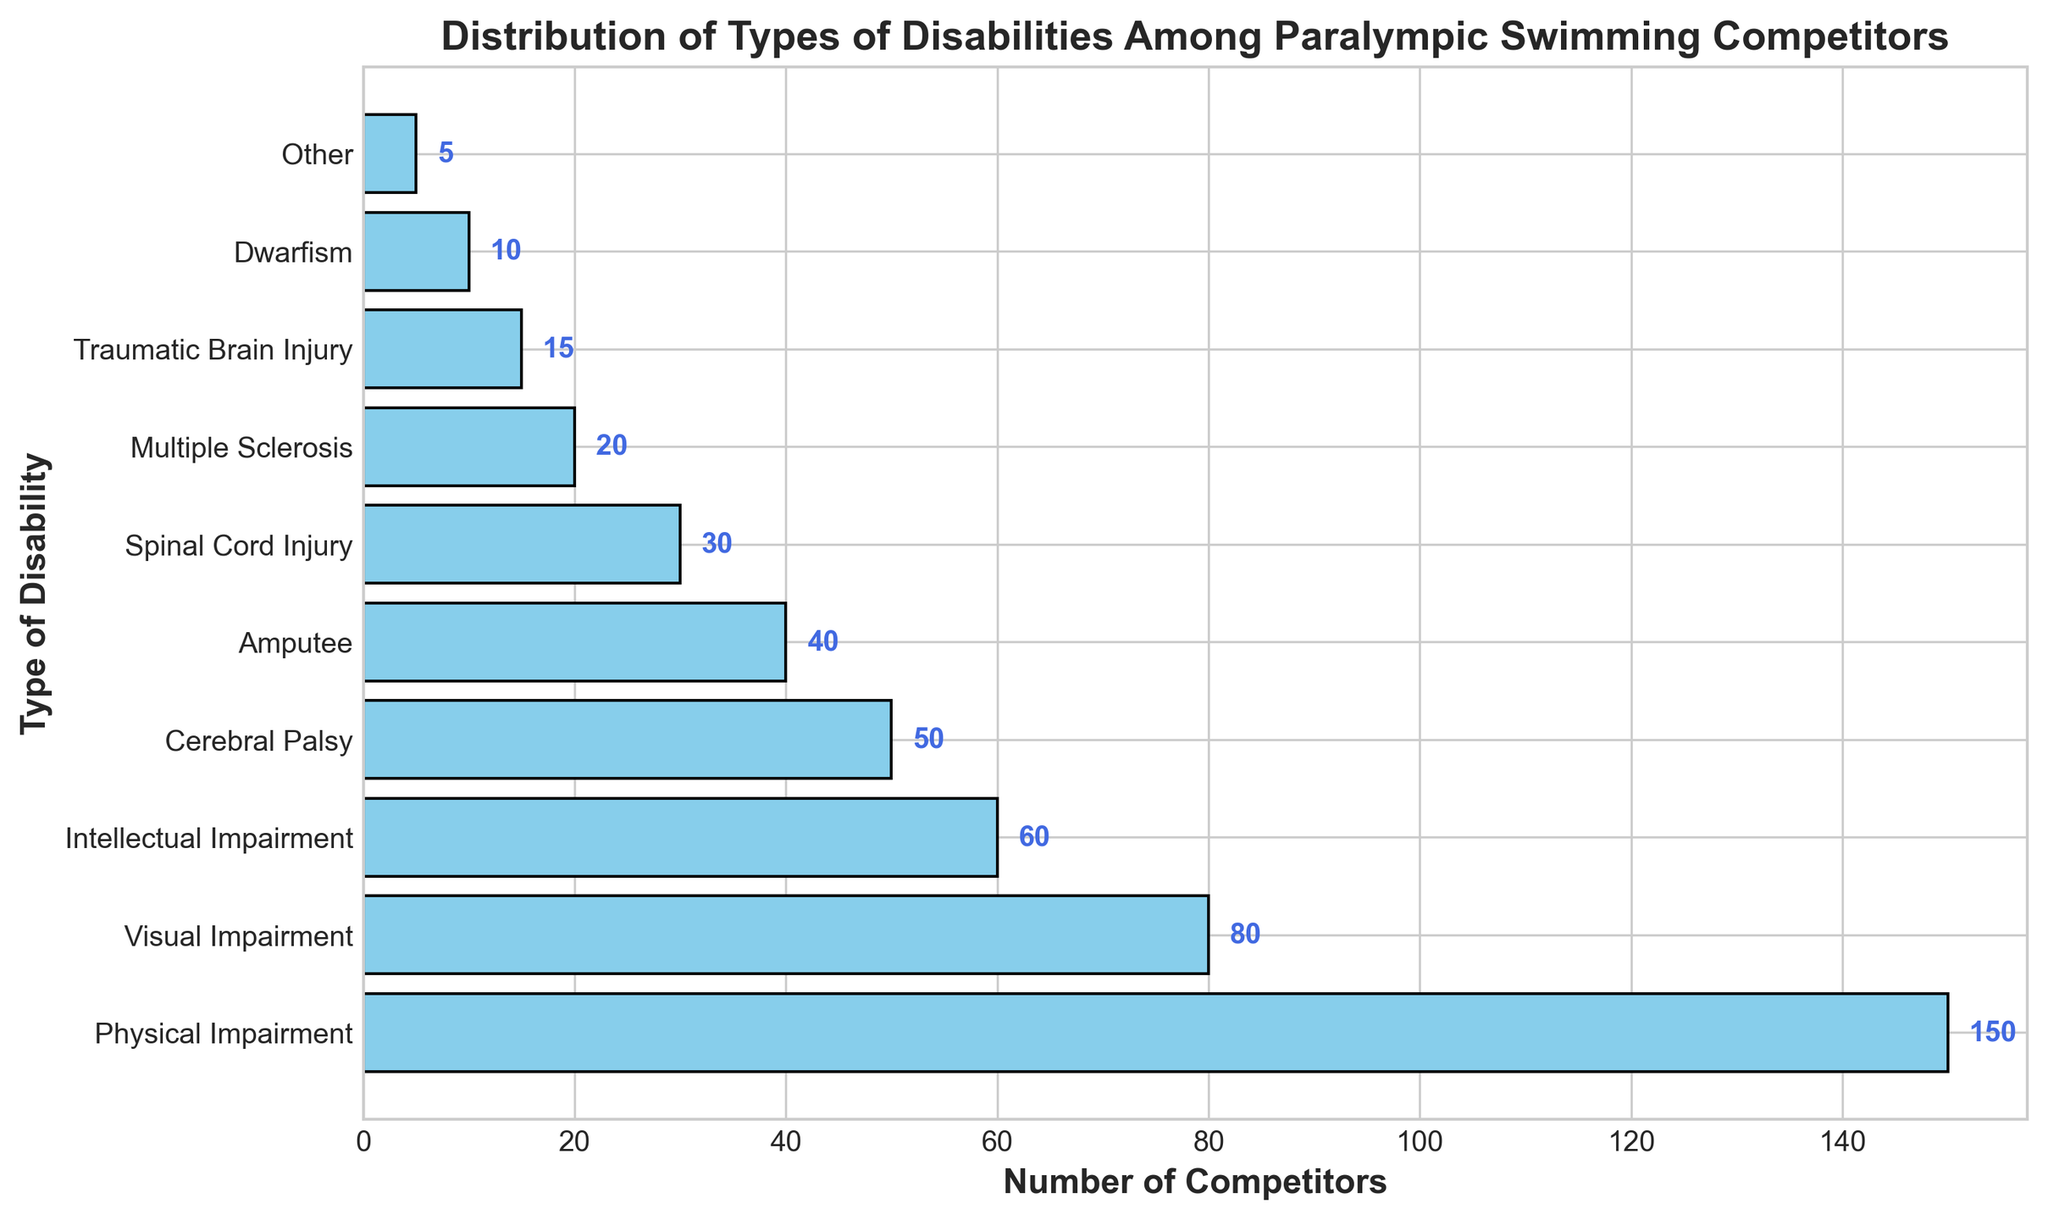Which type of disability has the highest number of competitors? The tallest bar on the horizontal bar chart represents the type of disability with the highest number of competitors. The bar for "Physical Impairment" is the tallest, indicating it has the highest count.
Answer: Physical Impairment How many more competitors have a Physical Impairment compared to a Visual Impairment? Find the counts for both types of disabilities and subtract the smaller count from the larger one. "Physical Impairment" has 150 competitors and "Visual Impairment" has 80 competitors. So, 150 - 80 = 70.
Answer: 70 What is the total number of competitors from all disability types combined? Add up the counts of all disability categories. The sum is 150 + 80 + 60 + 50 + 40 + 30 + 20 + 15 + 10 + 5 = 460.
Answer: 460 How does the number of competitors with Intellectual Impairment compare to those with Cerebral Palsy? Look at the length of the bars for both disabilities. "Intellectual Impairment" has 60 competitors, while "Cerebral Palsy" has 50 competitors. Thus, Intellectual Impairment has more competitors.
Answer: Intellectual Impairment Which three disability types have the lowest number of competitors? Identify the three bars with the shortest lengths. They represent "Dwarfism" with 10, "Traumatic Brain Injury" with 15, and "Other" with 5 competitors.
Answer: Dwarfism, Traumatic Brain Injury, Other What percentage of the total competitors have a Spinal Cord Injury? First, determine the total number of competitors (460). Then, find the count for Spinal Cord Injury (30). The percentage is calculated as (30/460) * 100 ≈ 6.52%.
Answer: 6.52% How many types of disabilities have fewer than 50 competitors? Count the number of bars that represent fewer than 50 competitors. The categories with fewer than 50 competitors are Amputee (40), Spinal Cord Injury (30), Multiple Sclerosis (20), Traumatic Brain Injury (15), Dwarfism (10), and Other (5). This gives us 6 types.
Answer: 6 If you combine competitors with Intellectual Impairments and Visual Impairments, what is the total number of competitors for these two types? Add the counts for Intellectual Impairment and Visual Impairment. 60 (Intellectual Impairment) + 80 (Visual Impairment) = 140.
Answer: 140 